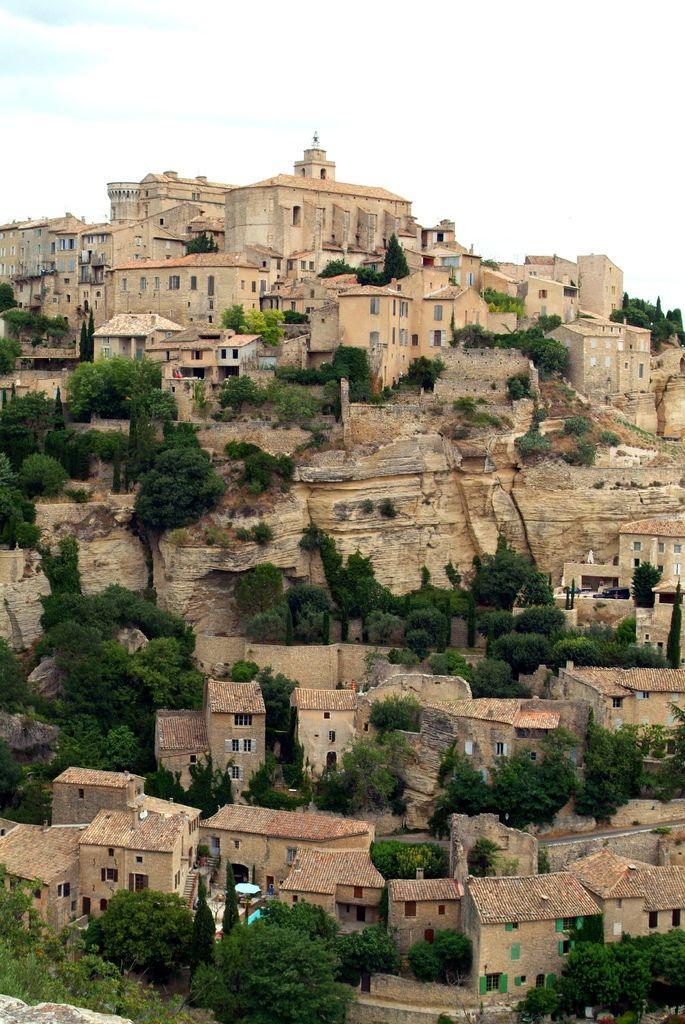Can you describe this image briefly? In this image there are trees and houses. 